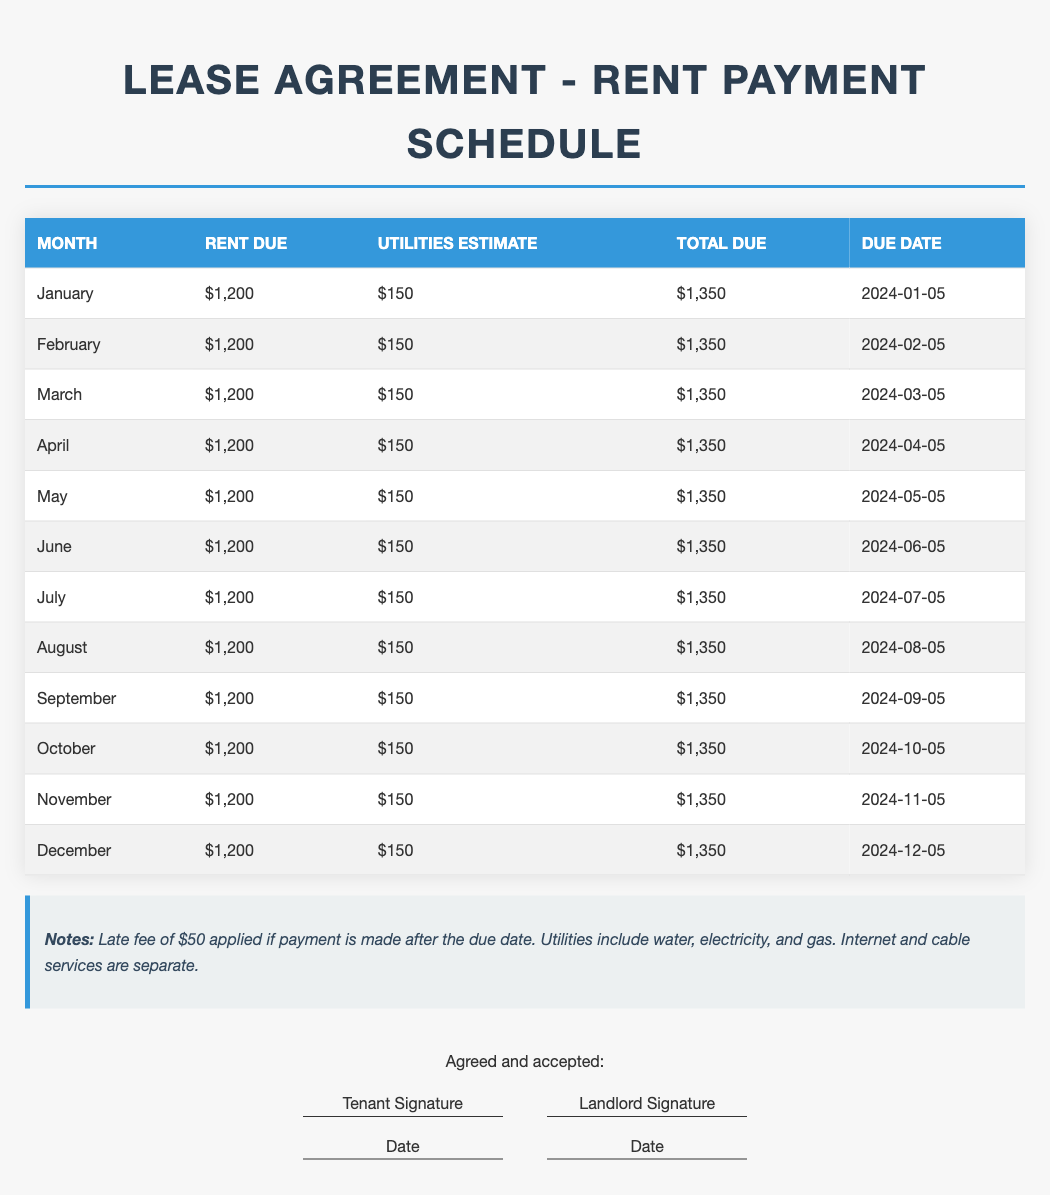What is the total rent due in January? The total rent due in January includes both the rent and utilities estimate, which is $1,200 + $150 = $1,350.
Answer: $1,350 When is the rent due for April? The due date for April rent is specified in the table as the fifth day of the month.
Answer: 2024-04-05 What is the estimated utility cost each month? The estimated utility cost is listed in the table for each month, which is $150.
Answer: $150 How much is the late fee if the rent is paid after the due date? The notes section indicates the late fee applied for late payment.
Answer: $50 How many months does the lease cover in this document? The document provides a rent schedule covering each month of the year, from January to December, indicating a total of twelve months.
Answer: 12 Months What is the total amount due for rent in July? The total rent for July, including utilities, is identified in the table as $1,350.
Answer: $1,350 Which services are included in the utility estimate? The notes explain what the utilities estimate covers, influencing the tenant's payment expectations.
Answer: Water, electricity, and gas What is the amount due in December? The total due for December is repeated for clarity in the table, which is $1,350.
Answer: $1,350 